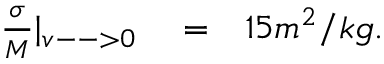<formula> <loc_0><loc_0><loc_500><loc_500>\begin{array} { r l r } { \frac { \sigma } { M } | _ { v - - > 0 } } & = } & { 1 5 m ^ { 2 } / k g . } \end{array}</formula> 